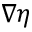Convert formula to latex. <formula><loc_0><loc_0><loc_500><loc_500>\nabla \eta</formula> 